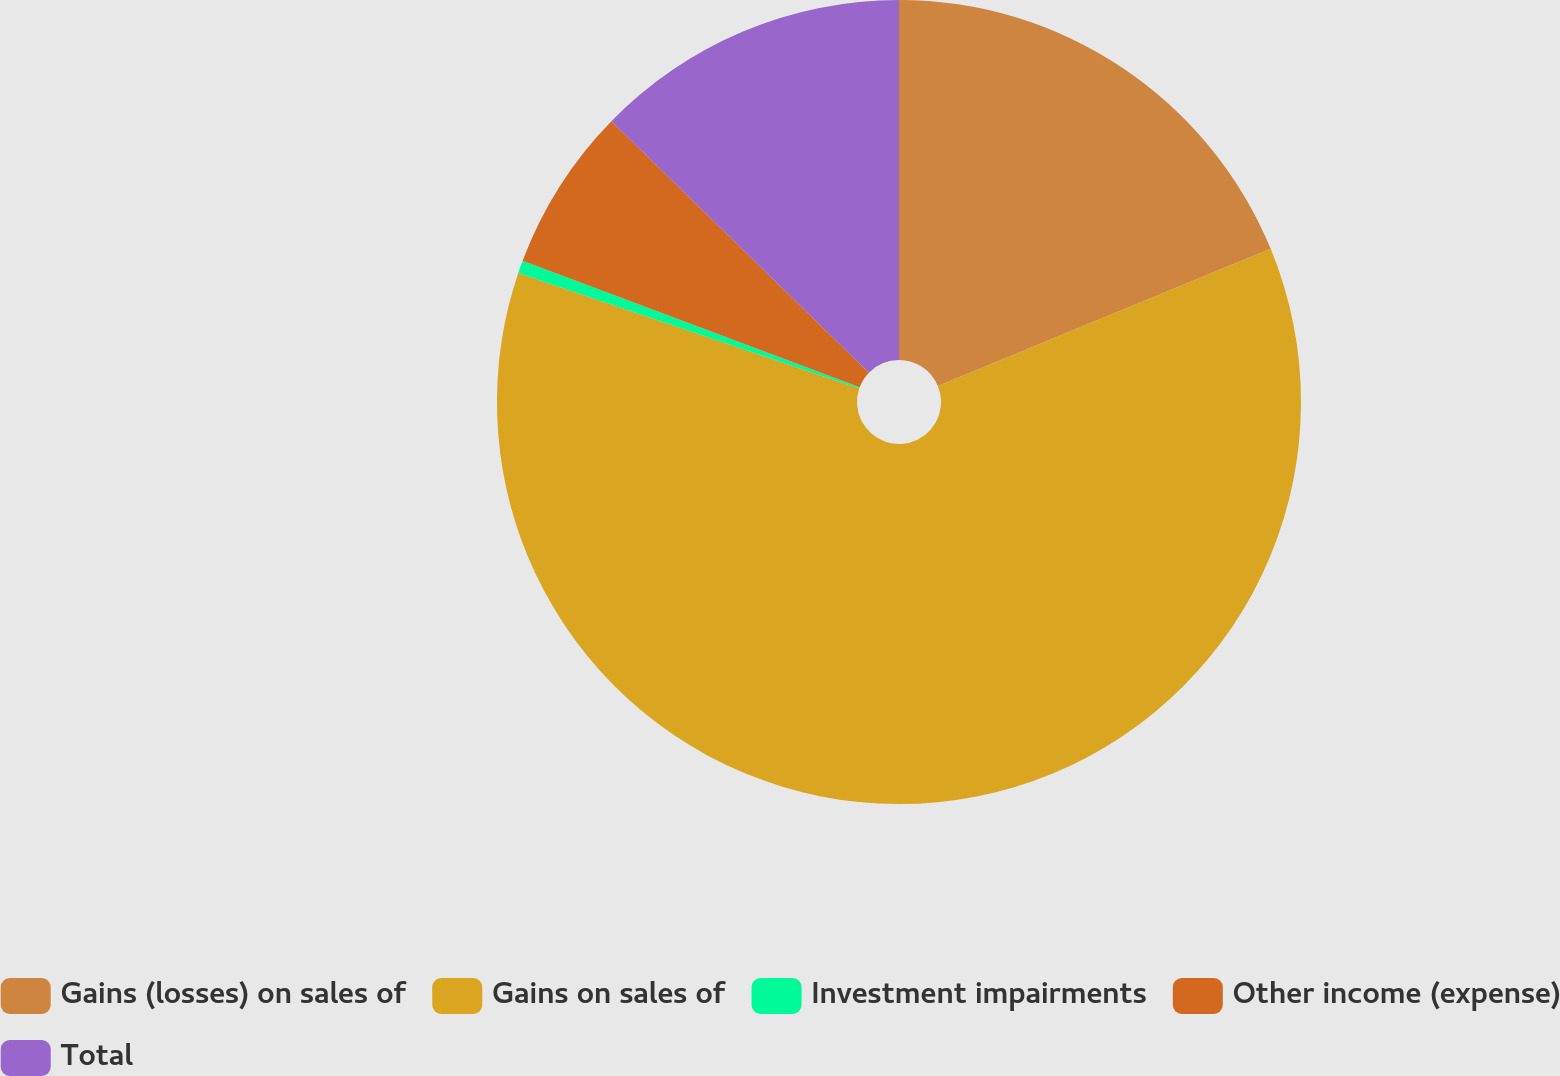Convert chart to OTSL. <chart><loc_0><loc_0><loc_500><loc_500><pie_chart><fcel>Gains (losses) on sales of<fcel>Gains on sales of<fcel>Investment impairments<fcel>Other income (expense)<fcel>Total<nl><fcel>18.78%<fcel>61.42%<fcel>0.51%<fcel>6.6%<fcel>12.69%<nl></chart> 